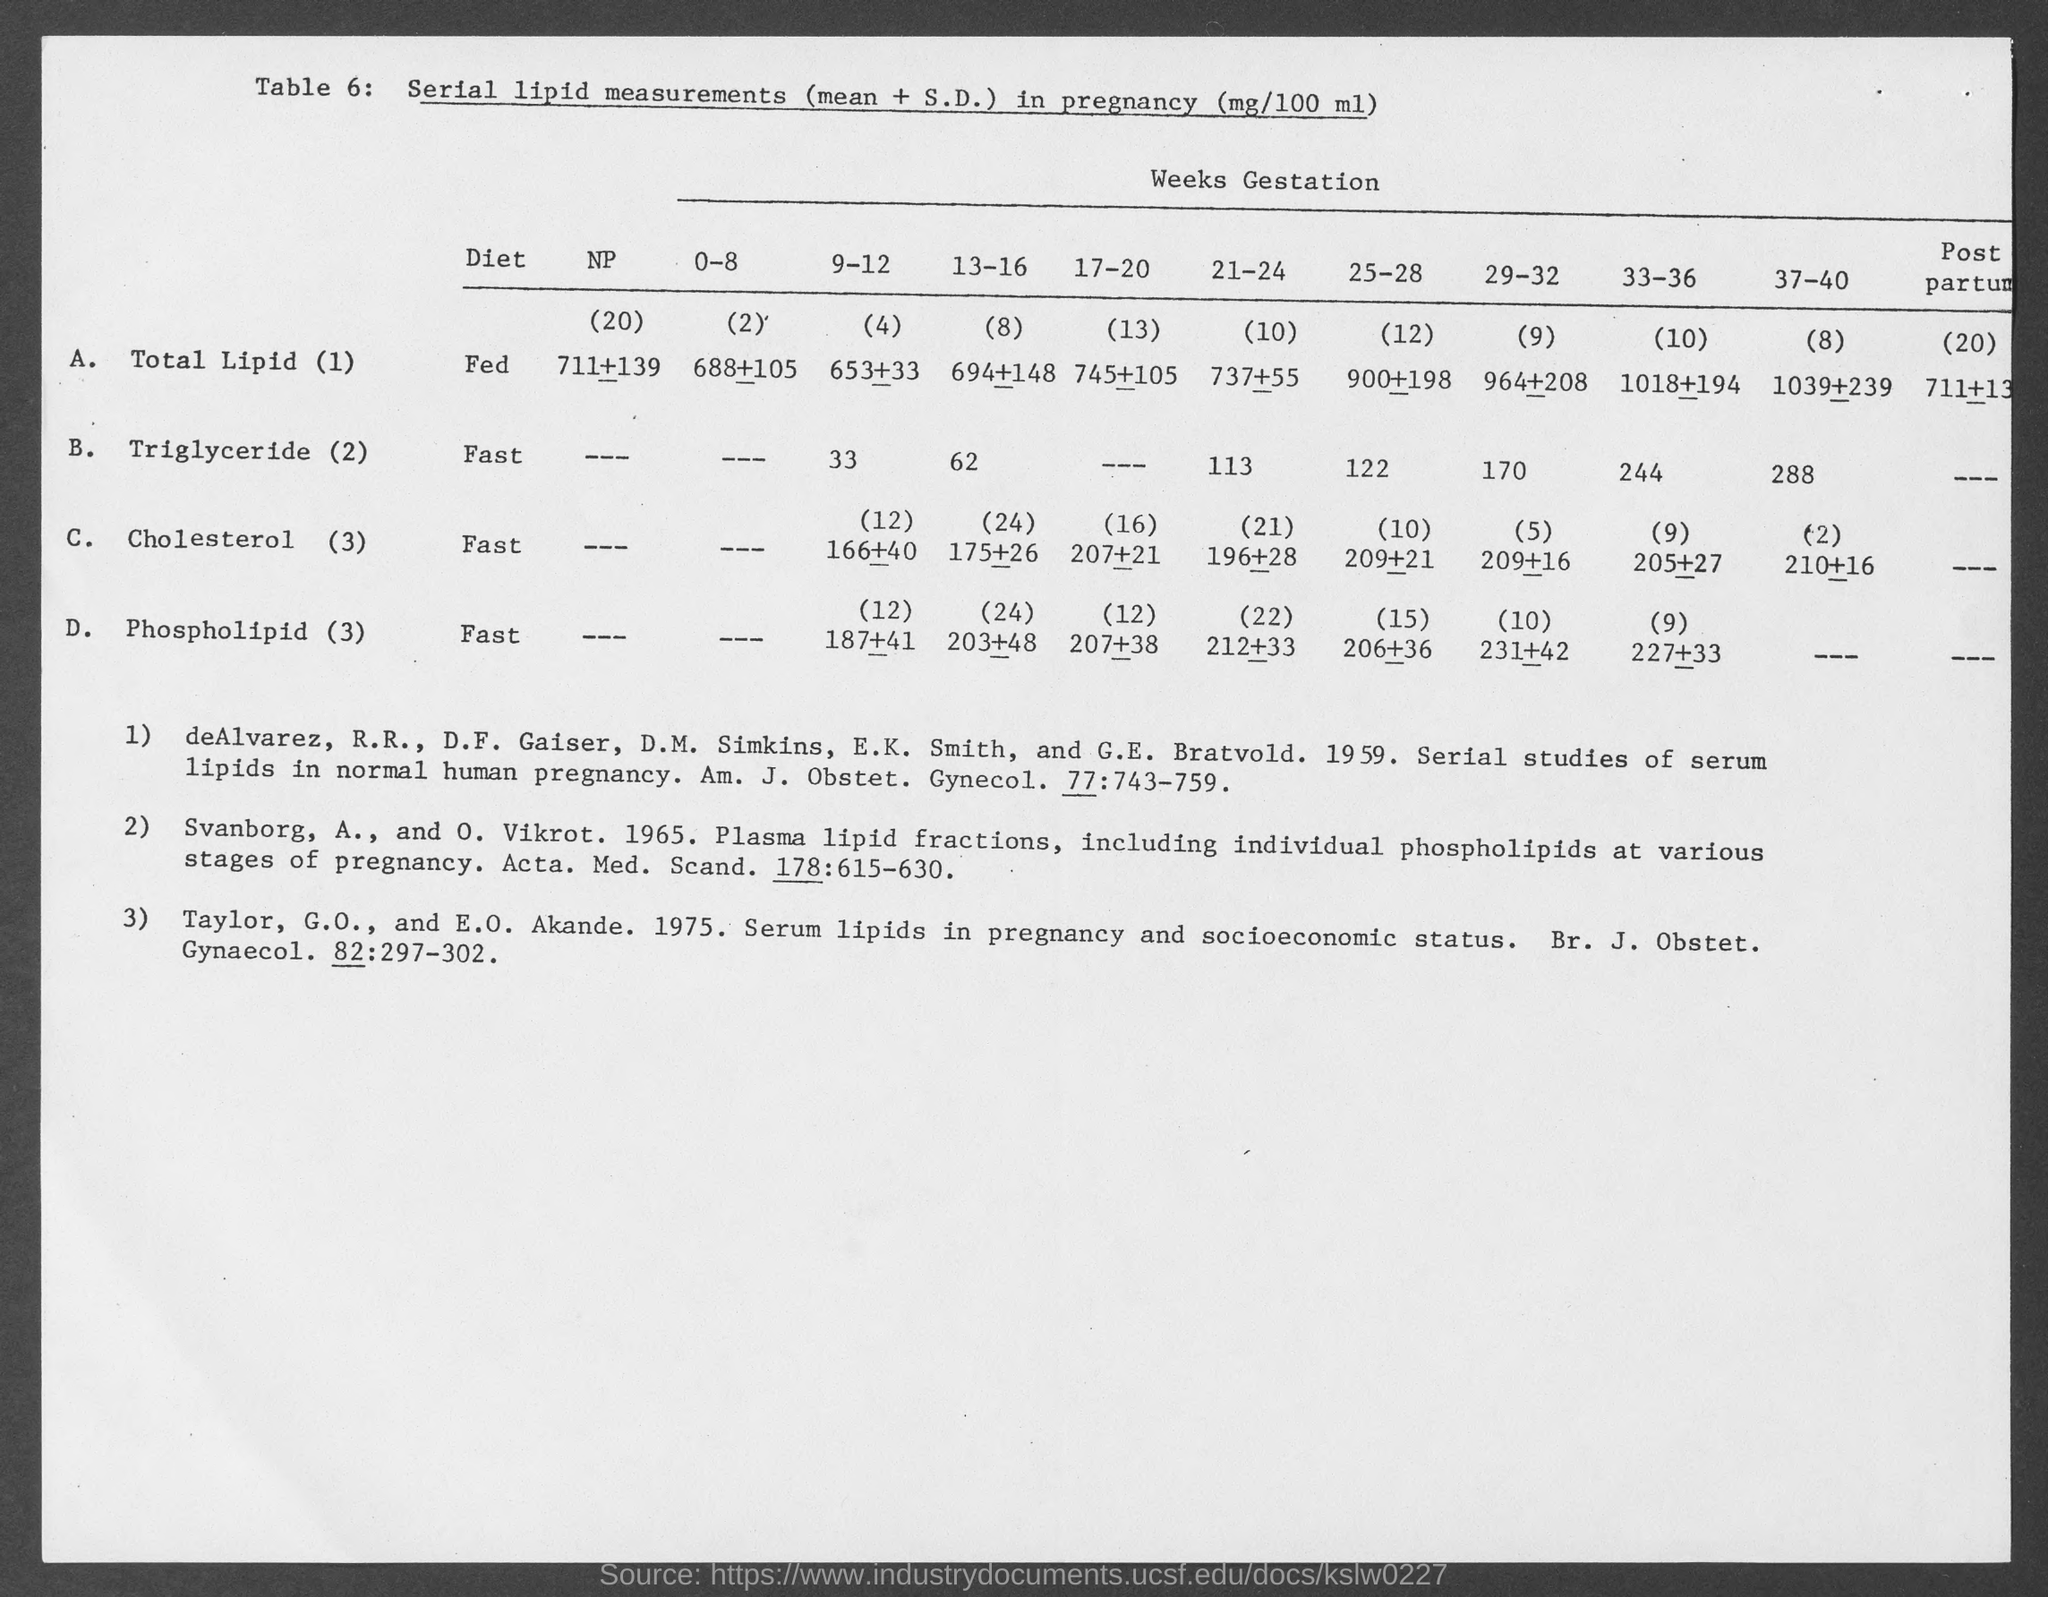What is the table number?
Give a very brief answer. 6. What is the type of diet for Cholesterol  (3)?
Your response must be concise. Fast. What is the type of diet for Total Lipid (1)?
Give a very brief answer. Fed. What is the type of diet for Triglyceride (2)?
Make the answer very short. Fast. What is the type of diet for Phospholipid (3)?
Provide a succinct answer. Fast. 